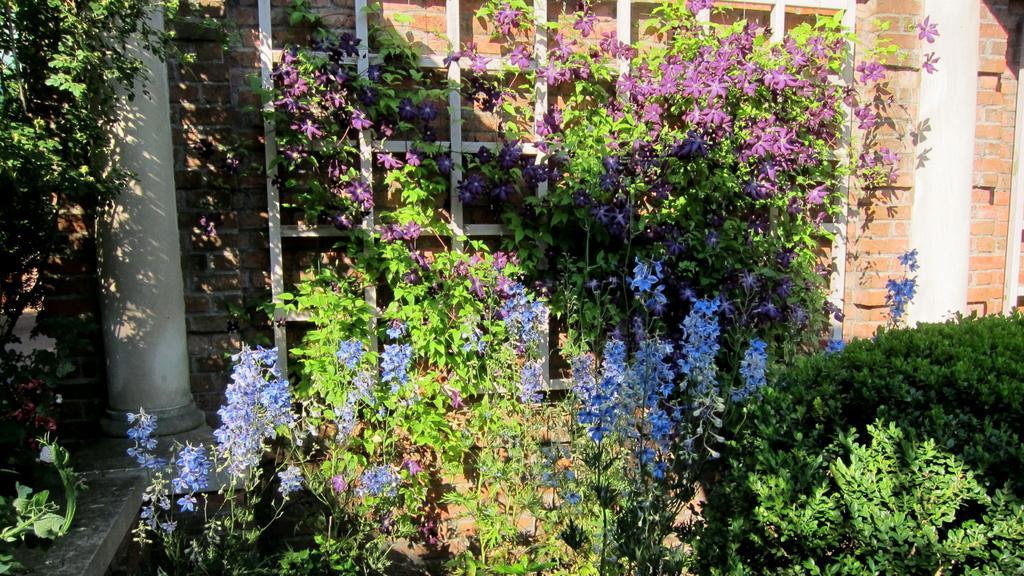In one or two sentences, can you explain what this image depicts? In the picture I can see blue and purple color flowers to the plants, we can see the shrubs, pillars and the brick wall in the background. 